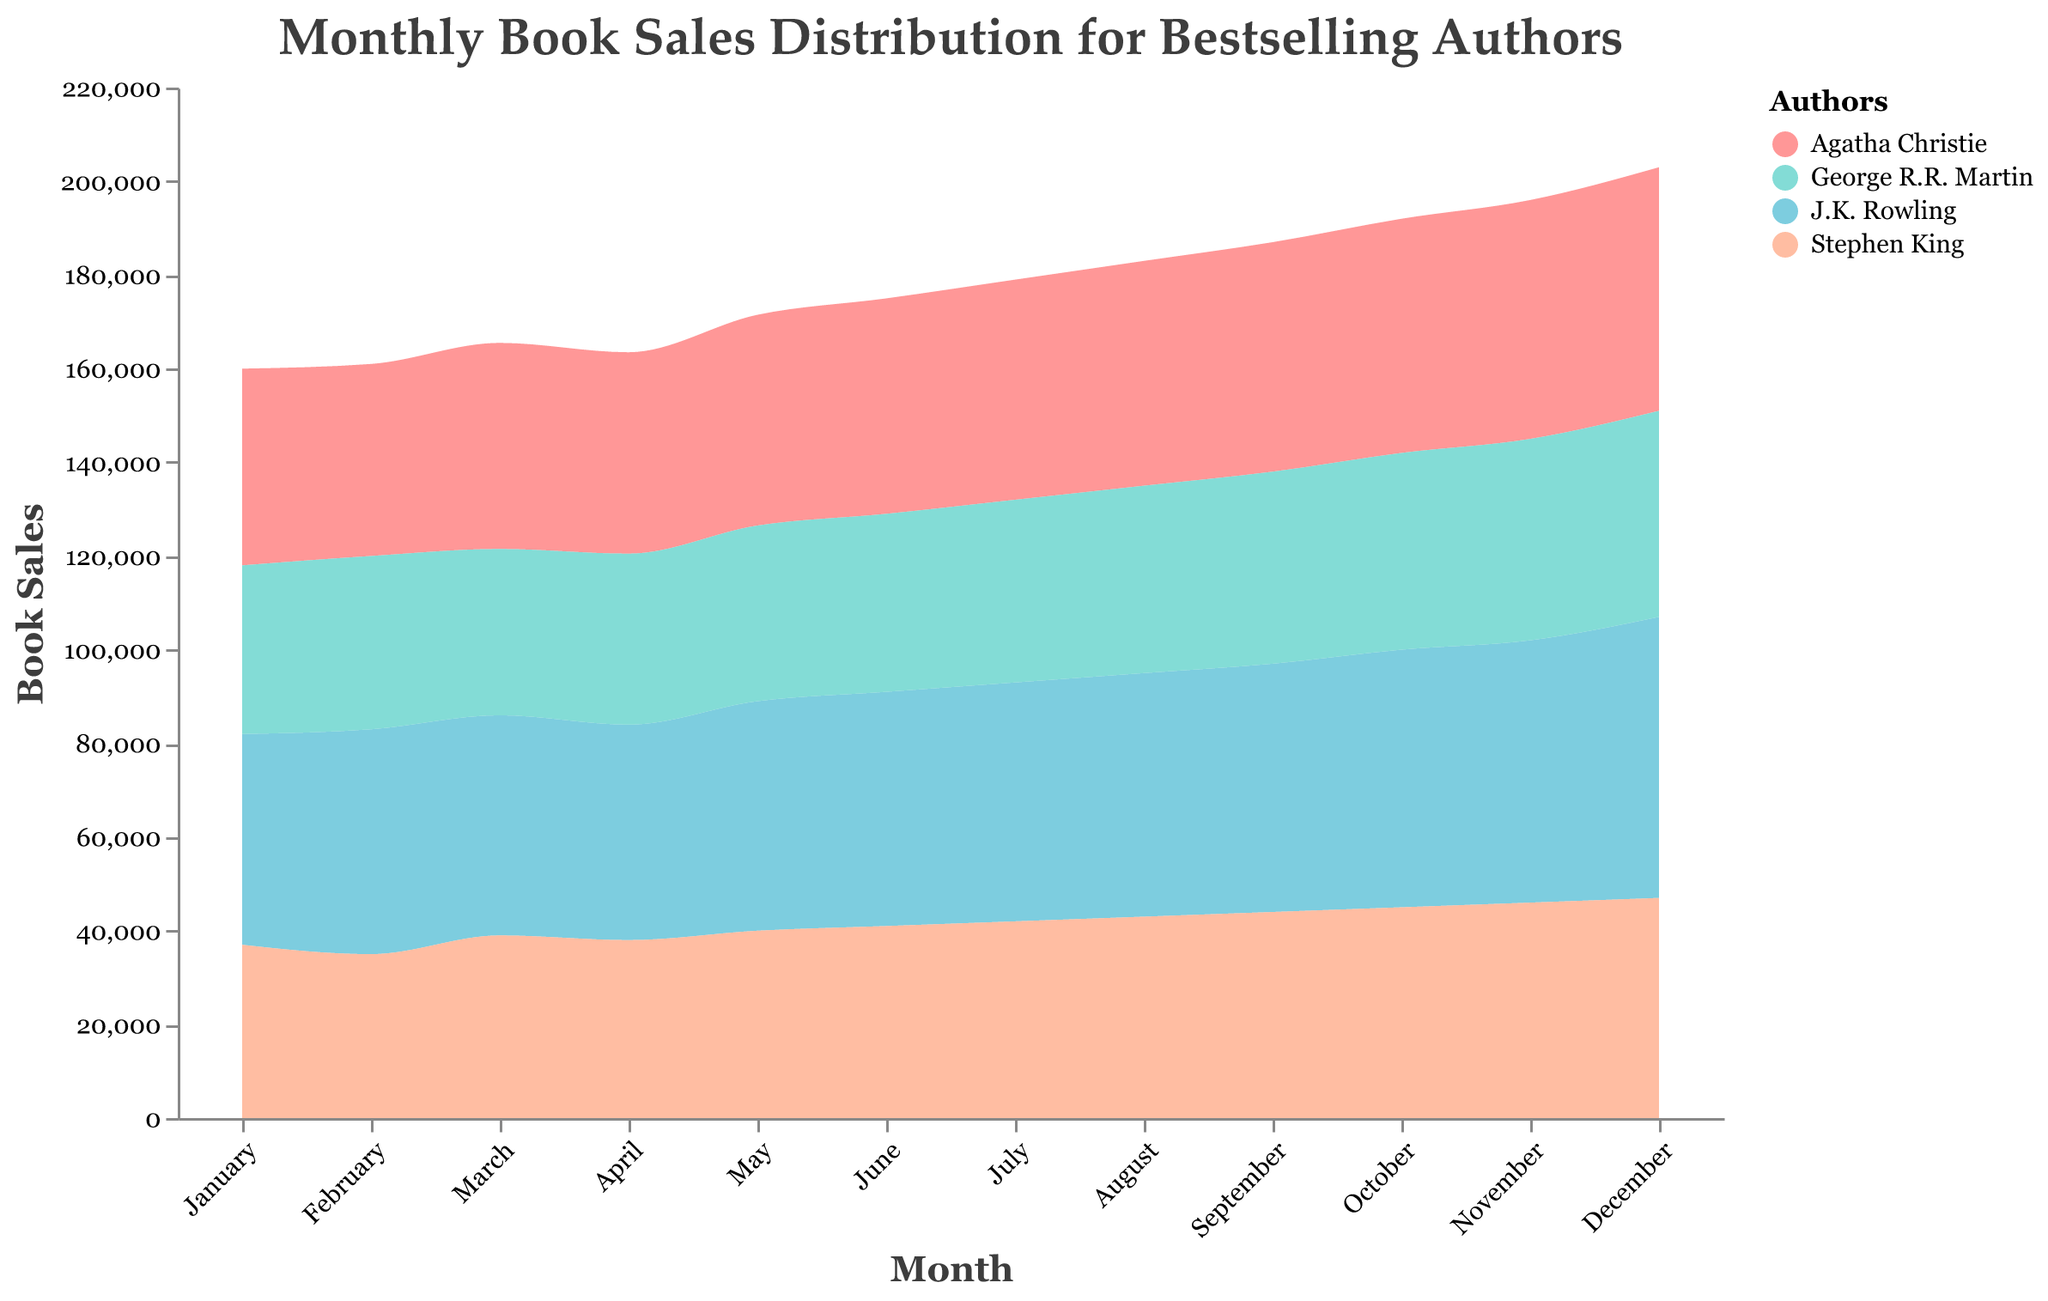What is the title of the figure? The title is usually placed at the top of the figure and describes what the plot is about. It reads "Monthly Book Sales Distribution for Bestselling Authors".
Answer: Monthly Book Sales Distribution for Bestselling Authors Which author shows the highest book sales in December? By looking at the points corresponding to December and comparing the heights of the areas for each author, J.K. Rowling has the highest book sales in December.
Answer: J.K. Rowling How do the book sales of Stephen King in March compare to those in April? Locate the values for March and April in the plot for Stephen King. In March, the book sales are 39,000 and in April, they are 38,000. This shows a slight decrease in sales from March to April.
Answer: They decreased by 1,000 In which month does Agatha Christie have the highest book sales? Scan the area representing Agatha Christie across all months to identify the peak point. Her highest book sales are observed in December.
Answer: December What is the trend of George R.R. Martin's book sales from January to December? Analyzing the trend across the months in the plot, George R.R. Martin’s book sales show a steady increase from January (36,000) to December (44,000). Thus, the sales generally trend upwards.
Answer: Increasing trend Which month has the overall highest book sales for all authors combined? Provide a detailed calculation. Sum the book sales for all authors for each month and identify the maximum. For December: J.K. Rowling (60,000) + Stephen King (47,000) + Agatha Christie (52,000) + George R.R. Martin (44,000) = 203,000. By calculating similarly for other months, December has the highest combined book sales (203,000).
Answer: December Compare the average monthly book sales of J.K. Rowling to Agatha Christie. Calculate the average sales for J.K. Rowling and Agatha Christie by summing their monthly sales and dividing by 12. J.K. Rowling: (45000 + 48000 + 47000 + 46000 + 49000 + 50000 + 51000 + 52000 + 53000 + 55000 + 56000 + 60000)/12 = 50833.33. Agatha Christie: (42000 + 41000 + 44000 + 43000 + 45000 + 46000 + 47000 + 48000 + 49000 + 50000 + 51000 + 52000)/12 = 46833.33. This shows that J.K. Rowling has higher monthly average sales.
Answer: J.K. Rowling has higher average monthly sales Identify any periods of consistent increase in book sales for Stephen King. Analyze the plot to see consistent upwards movement for Stephen King. He shows consistent increases in book sales from May (40,000) to December (47,000).
Answer: May to December What is the color used to represent George R.R. Martin in the distribution plot? The color associated with George R.R. Martin can be found in the plot's legend. It appears as a shade of light coral (or peach).
Answer: Light coral (or peach) 